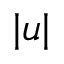Convert formula to latex. <formula><loc_0><loc_0><loc_500><loc_500>| u |</formula> 